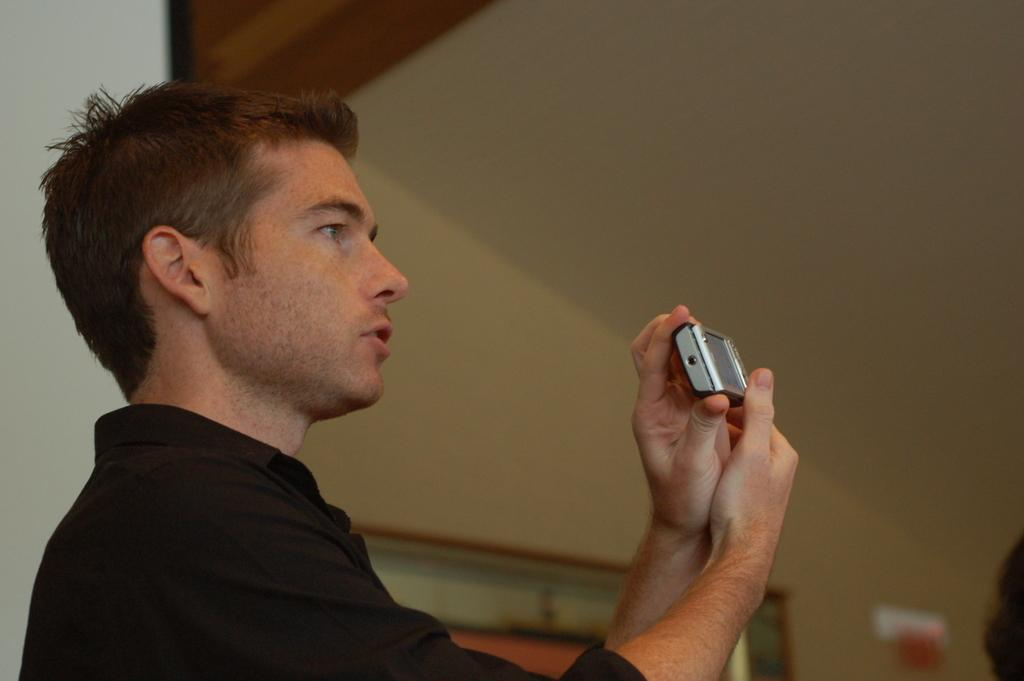What is the main subject of the image? There is a person in the image. What is the person doing in the image? The person is standing. What object is the person holding in the image? The person is holding a mobile phone in his hand. What type of vase can be seen on the person's head in the image? There is no vase present on the person's head in the image. Can you describe the bird that is perched on the person's shoulder in the image? There is no bird present on the person's shoulder in the image. 